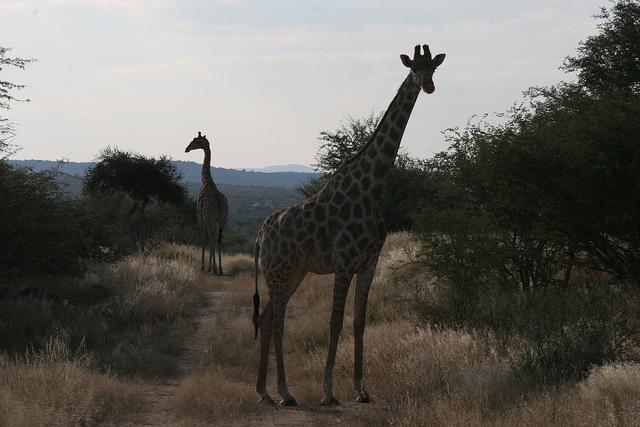How many giraffes are there?
Give a very brief answer. 2. How many giraffes can you see?
Give a very brief answer. 2. 